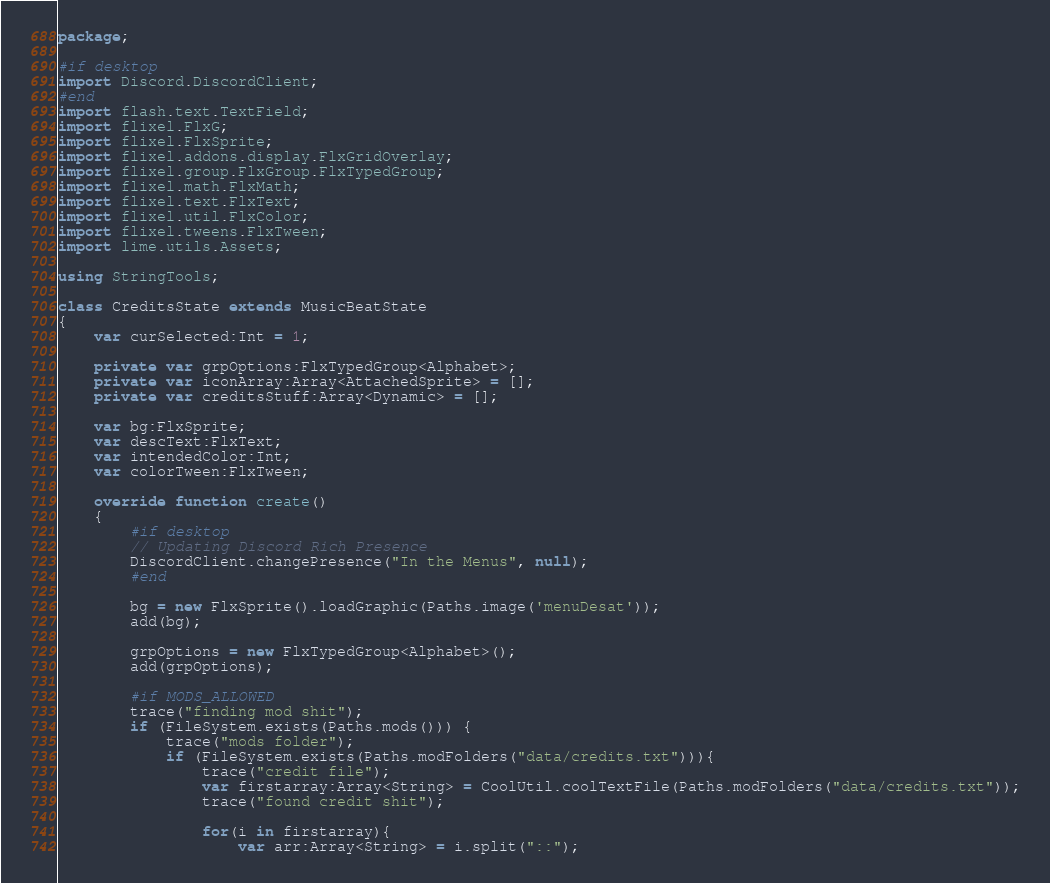<code> <loc_0><loc_0><loc_500><loc_500><_Haxe_>package;

#if desktop
import Discord.DiscordClient;
#end
import flash.text.TextField;
import flixel.FlxG;
import flixel.FlxSprite;
import flixel.addons.display.FlxGridOverlay;
import flixel.group.FlxGroup.FlxTypedGroup;
import flixel.math.FlxMath;
import flixel.text.FlxText;
import flixel.util.FlxColor;
import flixel.tweens.FlxTween;
import lime.utils.Assets;

using StringTools;

class CreditsState extends MusicBeatState
{
	var curSelected:Int = 1;

	private var grpOptions:FlxTypedGroup<Alphabet>;
	private var iconArray:Array<AttachedSprite> = [];
	private var creditsStuff:Array<Dynamic> = [];

	var bg:FlxSprite;
	var descText:FlxText;
	var intendedColor:Int;
	var colorTween:FlxTween;

	override function create()
	{
		#if desktop
		// Updating Discord Rich Presence
		DiscordClient.changePresence("In the Menus", null);
		#end

		bg = new FlxSprite().loadGraphic(Paths.image('menuDesat'));
		add(bg);

		grpOptions = new FlxTypedGroup<Alphabet>();
		add(grpOptions);

		#if MODS_ALLOWED
		trace("finding mod shit");
		if (FileSystem.exists(Paths.mods())) {
			trace("mods folder");
			if (FileSystem.exists(Paths.modFolders("data/credits.txt"))){
				trace("credit file");
				var firstarray:Array<String> = CoolUtil.coolTextFile(Paths.modFolders("data/credits.txt"));
				trace("found credit shit");
				
				for(i in firstarray){
					var arr:Array<String> = i.split("::");</code> 